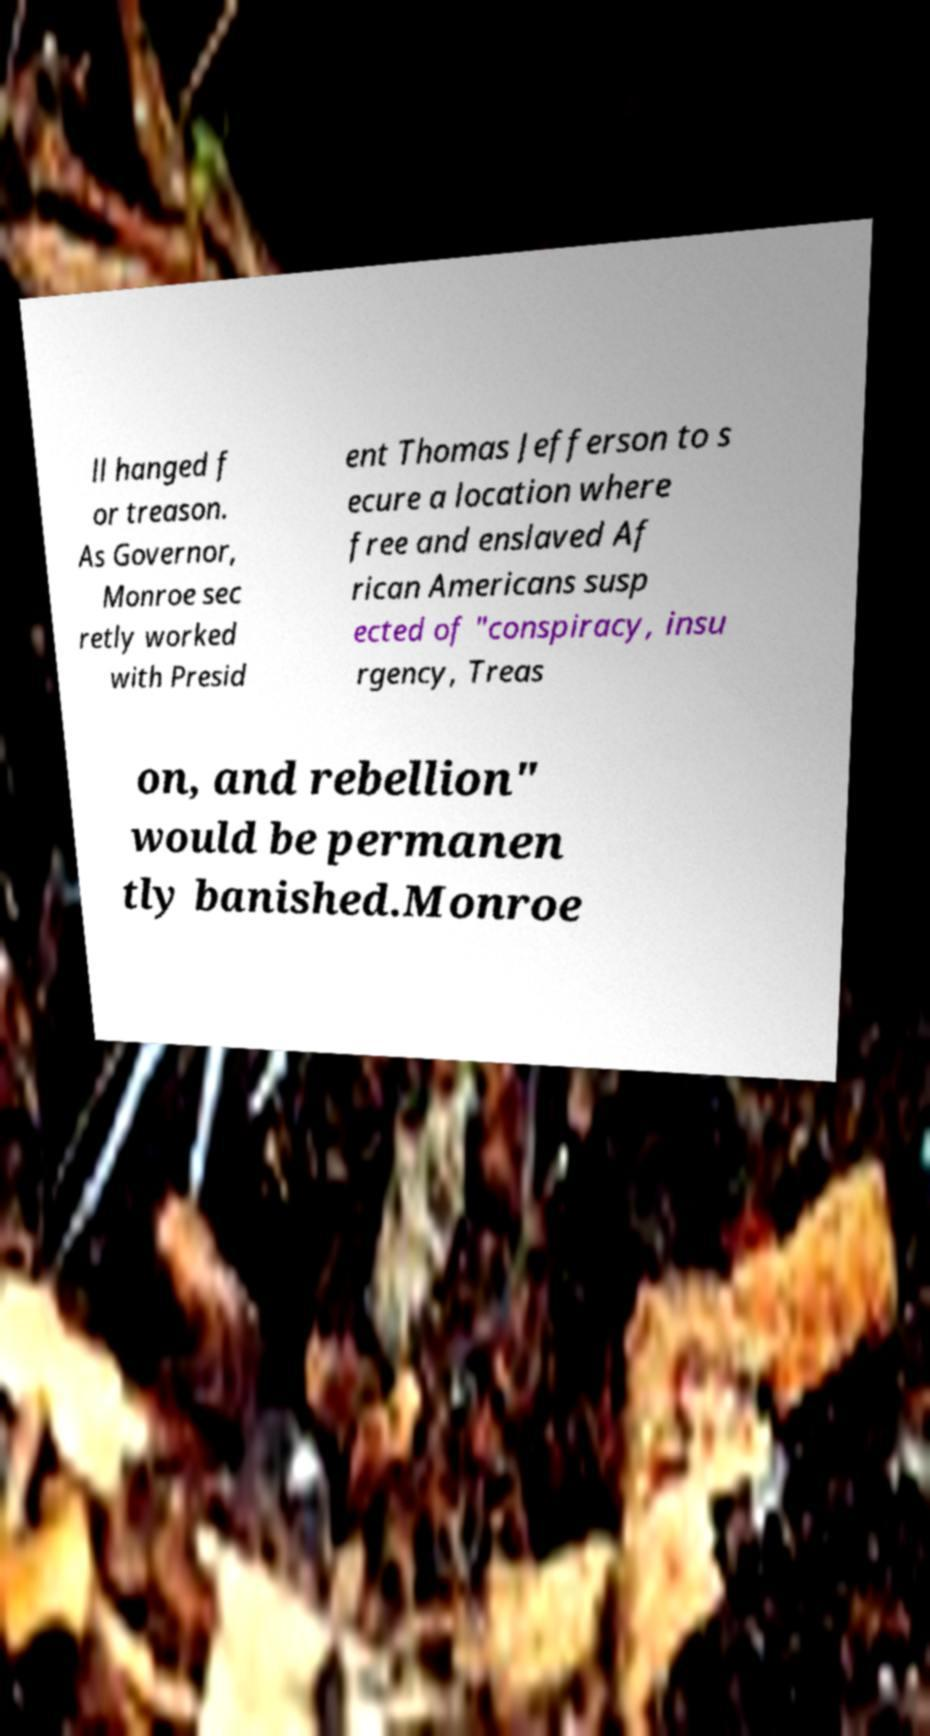I need the written content from this picture converted into text. Can you do that? ll hanged f or treason. As Governor, Monroe sec retly worked with Presid ent Thomas Jefferson to s ecure a location where free and enslaved Af rican Americans susp ected of "conspiracy, insu rgency, Treas on, and rebellion" would be permanen tly banished.Monroe 